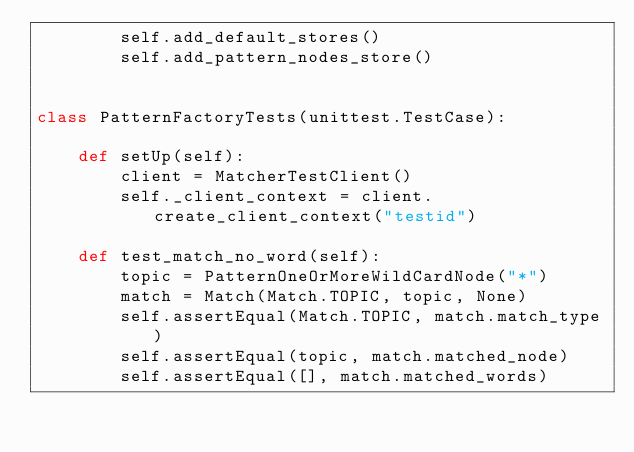Convert code to text. <code><loc_0><loc_0><loc_500><loc_500><_Python_>        self.add_default_stores()
        self.add_pattern_nodes_store()


class PatternFactoryTests(unittest.TestCase):

    def setUp(self):
        client = MatcherTestClient()
        self._client_context = client.create_client_context("testid")

    def test_match_no_word(self):
        topic = PatternOneOrMoreWildCardNode("*")
        match = Match(Match.TOPIC, topic, None)
        self.assertEqual(Match.TOPIC, match.match_type)
        self.assertEqual(topic, match.matched_node)
        self.assertEqual([], match.matched_words)</code> 